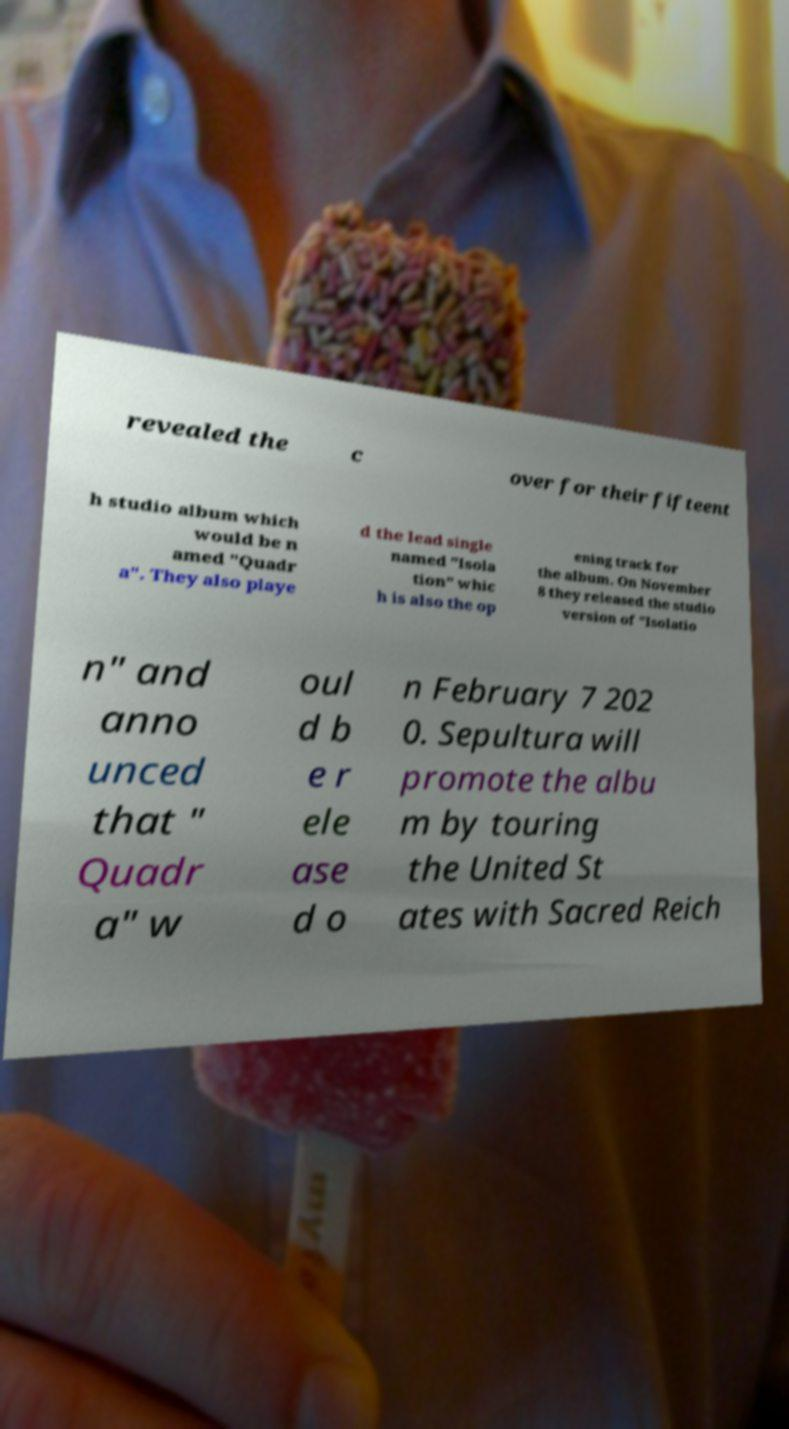Can you accurately transcribe the text from the provided image for me? revealed the c over for their fifteent h studio album which would be n amed "Quadr a". They also playe d the lead single named "Isola tion" whic h is also the op ening track for the album. On November 8 they released the studio version of "Isolatio n" and anno unced that " Quadr a" w oul d b e r ele ase d o n February 7 202 0. Sepultura will promote the albu m by touring the United St ates with Sacred Reich 